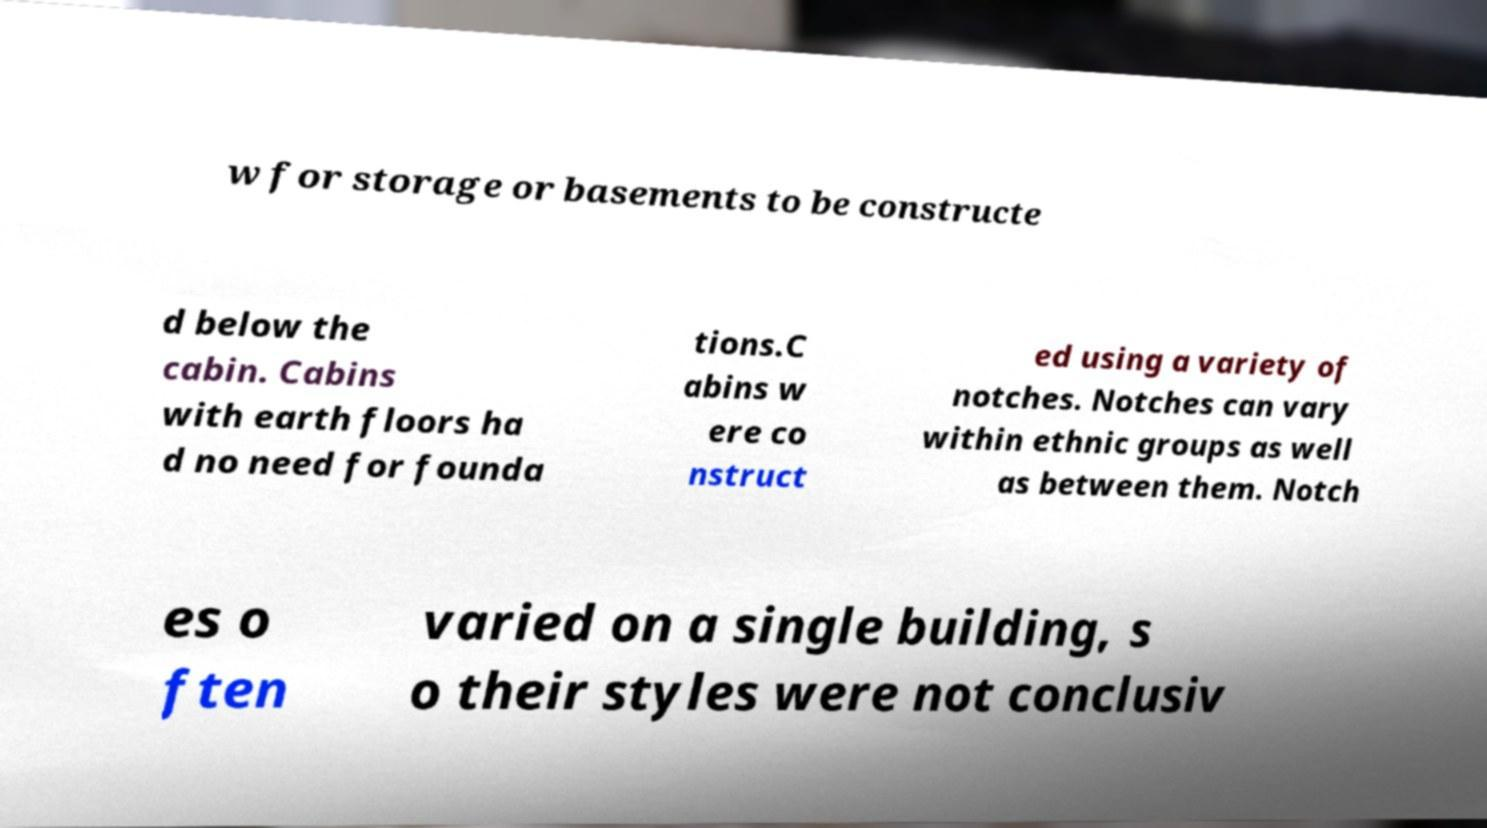There's text embedded in this image that I need extracted. Can you transcribe it verbatim? w for storage or basements to be constructe d below the cabin. Cabins with earth floors ha d no need for founda tions.C abins w ere co nstruct ed using a variety of notches. Notches can vary within ethnic groups as well as between them. Notch es o ften varied on a single building, s o their styles were not conclusiv 